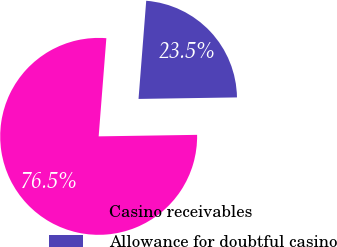Convert chart. <chart><loc_0><loc_0><loc_500><loc_500><pie_chart><fcel>Casino receivables<fcel>Allowance for doubtful casino<nl><fcel>76.49%<fcel>23.51%<nl></chart> 